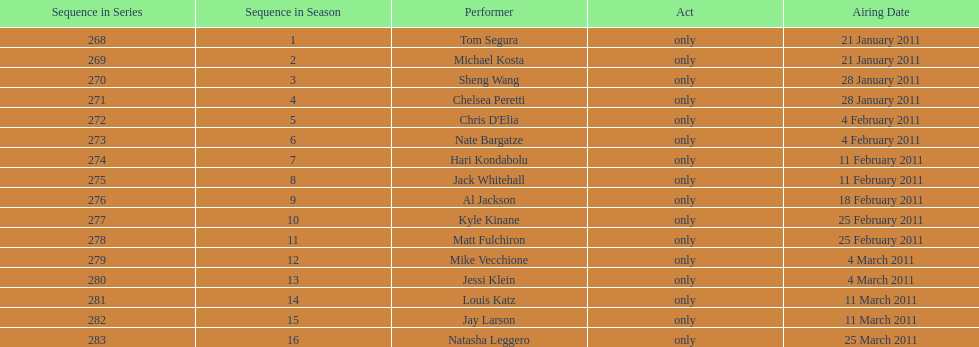What is the name of the last performer on this chart? Natasha Leggero. 